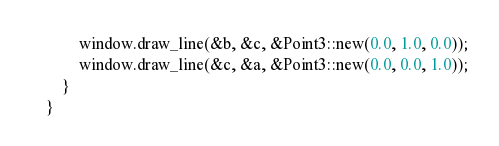Convert code to text. <code><loc_0><loc_0><loc_500><loc_500><_Rust_>        window.draw_line(&b, &c, &Point3::new(0.0, 1.0, 0.0));
        window.draw_line(&c, &a, &Point3::new(0.0, 0.0, 1.0));
    }
}
</code> 